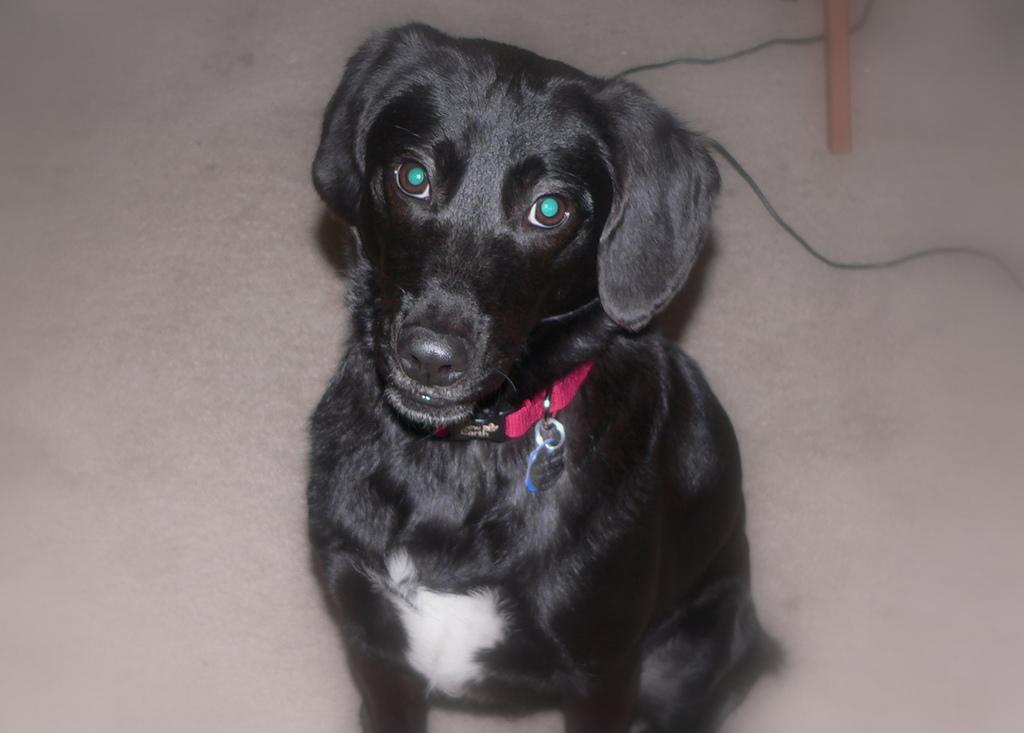What type of animal is in the image? The type of animal cannot be determined from the provided facts. What is the wire used for in the image? The purpose of the wire cannot be determined from the provided facts. What is the wooden object used for in the image? The purpose of the wooden object cannot be determined from the provided facts. What song is the animal singing in the image? There is no indication that the animal is singing a song in the image. How does the animal blow air in the image? There is no indication that the animal is blowing air in the image. 